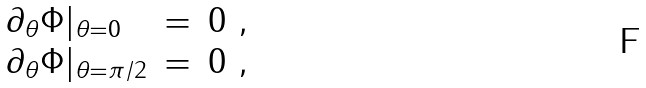<formula> <loc_0><loc_0><loc_500><loc_500>\begin{array} { l l l } \partial _ { \theta } \Phi | _ { \theta = 0 } & = & 0 \ , \\ \partial _ { \theta } \Phi | _ { \theta = \pi / 2 } & = & 0 \ , \end{array} \</formula> 